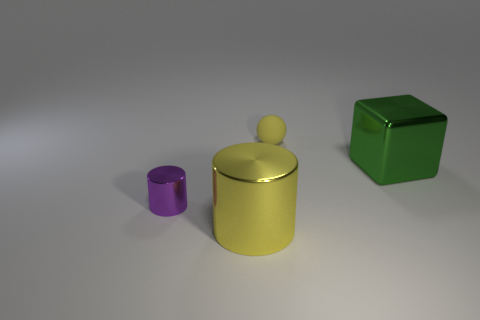Add 3 tiny purple shiny cylinders. How many objects exist? 7 Subtract 0 brown cylinders. How many objects are left? 4 Subtract all yellow spheres. Subtract all yellow matte objects. How many objects are left? 2 Add 2 metal cubes. How many metal cubes are left? 3 Add 4 small rubber things. How many small rubber things exist? 5 